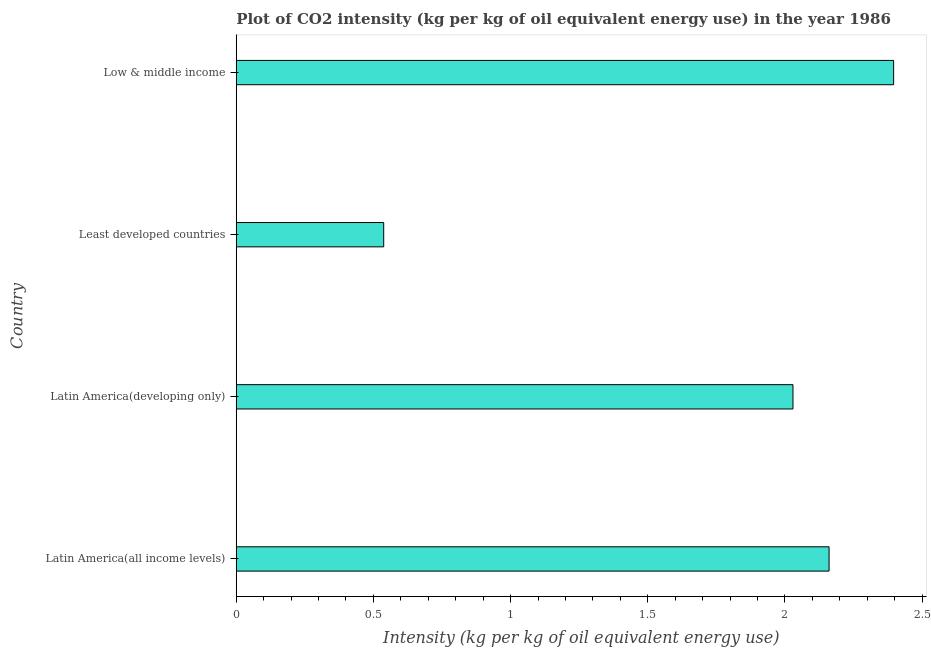What is the title of the graph?
Ensure brevity in your answer.  Plot of CO2 intensity (kg per kg of oil equivalent energy use) in the year 1986. What is the label or title of the X-axis?
Ensure brevity in your answer.  Intensity (kg per kg of oil equivalent energy use). What is the co2 intensity in Latin America(developing only)?
Provide a succinct answer. 2.03. Across all countries, what is the maximum co2 intensity?
Offer a very short reply. 2.4. Across all countries, what is the minimum co2 intensity?
Ensure brevity in your answer.  0.54. In which country was the co2 intensity minimum?
Provide a succinct answer. Least developed countries. What is the sum of the co2 intensity?
Your answer should be very brief. 7.12. What is the difference between the co2 intensity in Latin America(developing only) and Least developed countries?
Provide a short and direct response. 1.49. What is the average co2 intensity per country?
Provide a succinct answer. 1.78. What is the median co2 intensity?
Your answer should be very brief. 2.1. In how many countries, is the co2 intensity greater than 1.4 kg?
Give a very brief answer. 3. What is the ratio of the co2 intensity in Latin America(all income levels) to that in Latin America(developing only)?
Provide a succinct answer. 1.06. Is the difference between the co2 intensity in Latin America(developing only) and Least developed countries greater than the difference between any two countries?
Provide a short and direct response. No. What is the difference between the highest and the second highest co2 intensity?
Keep it short and to the point. 0.23. Is the sum of the co2 intensity in Latin America(all income levels) and Latin America(developing only) greater than the maximum co2 intensity across all countries?
Provide a short and direct response. Yes. What is the difference between the highest and the lowest co2 intensity?
Provide a succinct answer. 1.86. How many bars are there?
Ensure brevity in your answer.  4. What is the difference between two consecutive major ticks on the X-axis?
Offer a terse response. 0.5. Are the values on the major ticks of X-axis written in scientific E-notation?
Your response must be concise. No. What is the Intensity (kg per kg of oil equivalent energy use) in Latin America(all income levels)?
Ensure brevity in your answer.  2.16. What is the Intensity (kg per kg of oil equivalent energy use) of Latin America(developing only)?
Make the answer very short. 2.03. What is the Intensity (kg per kg of oil equivalent energy use) in Least developed countries?
Offer a terse response. 0.54. What is the Intensity (kg per kg of oil equivalent energy use) of Low & middle income?
Give a very brief answer. 2.4. What is the difference between the Intensity (kg per kg of oil equivalent energy use) in Latin America(all income levels) and Latin America(developing only)?
Your answer should be compact. 0.13. What is the difference between the Intensity (kg per kg of oil equivalent energy use) in Latin America(all income levels) and Least developed countries?
Make the answer very short. 1.62. What is the difference between the Intensity (kg per kg of oil equivalent energy use) in Latin America(all income levels) and Low & middle income?
Give a very brief answer. -0.24. What is the difference between the Intensity (kg per kg of oil equivalent energy use) in Latin America(developing only) and Least developed countries?
Give a very brief answer. 1.49. What is the difference between the Intensity (kg per kg of oil equivalent energy use) in Latin America(developing only) and Low & middle income?
Your answer should be compact. -0.37. What is the difference between the Intensity (kg per kg of oil equivalent energy use) in Least developed countries and Low & middle income?
Give a very brief answer. -1.86. What is the ratio of the Intensity (kg per kg of oil equivalent energy use) in Latin America(all income levels) to that in Latin America(developing only)?
Provide a short and direct response. 1.06. What is the ratio of the Intensity (kg per kg of oil equivalent energy use) in Latin America(all income levels) to that in Least developed countries?
Your answer should be compact. 4.02. What is the ratio of the Intensity (kg per kg of oil equivalent energy use) in Latin America(all income levels) to that in Low & middle income?
Give a very brief answer. 0.9. What is the ratio of the Intensity (kg per kg of oil equivalent energy use) in Latin America(developing only) to that in Least developed countries?
Offer a very short reply. 3.77. What is the ratio of the Intensity (kg per kg of oil equivalent energy use) in Latin America(developing only) to that in Low & middle income?
Provide a succinct answer. 0.85. What is the ratio of the Intensity (kg per kg of oil equivalent energy use) in Least developed countries to that in Low & middle income?
Make the answer very short. 0.22. 